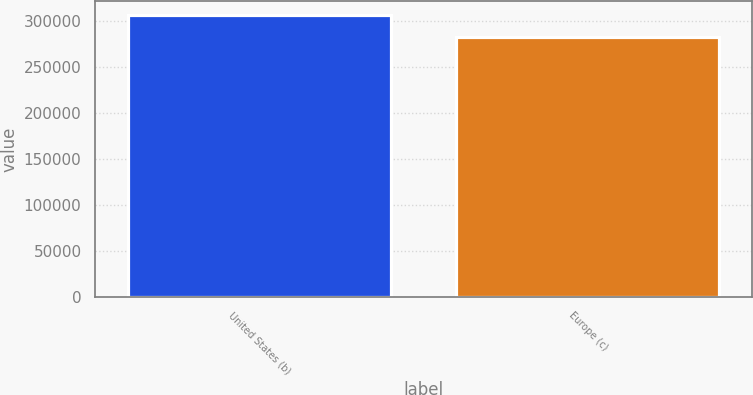Convert chart. <chart><loc_0><loc_0><loc_500><loc_500><bar_chart><fcel>United States (b)<fcel>Europe (c)<nl><fcel>305852<fcel>281844<nl></chart> 